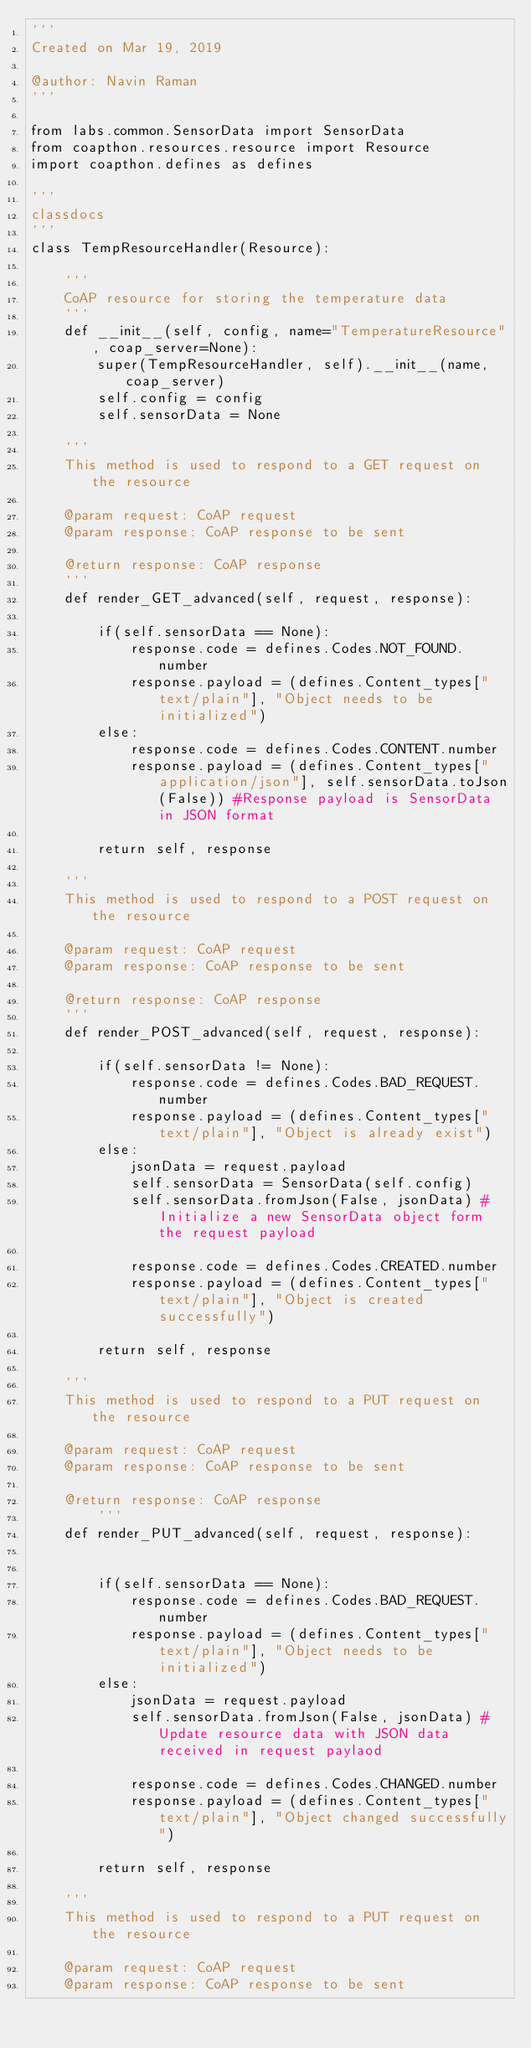<code> <loc_0><loc_0><loc_500><loc_500><_Python_>'''
Created on Mar 19, 2019

@author: Navin Raman
'''

from labs.common.SensorData import SensorData
from coapthon.resources.resource import Resource
import coapthon.defines as defines

'''
classdocs
'''
class TempResourceHandler(Resource):
    
    '''
    CoAP resource for storing the temperature data
    '''
    def __init__(self, config, name="TemperatureResource", coap_server=None):
        super(TempResourceHandler, self).__init__(name, coap_server)
        self.config = config
        self.sensorData = None
    
    '''
    This method is used to respond to a GET request on the resource
        
    @param request: CoAP request
    @param response: CoAP response to be sent

    @return response: CoAP response
    '''
    def render_GET_advanced(self, request, response):
        
        if(self.sensorData == None):
            response.code = defines.Codes.NOT_FOUND.number
            response.payload = (defines.Content_types["text/plain"], "Object needs to be initialized")
        else:
            response.code = defines.Codes.CONTENT.number
            response.payload = (defines.Content_types["application/json"], self.sensorData.toJson(False)) #Response payload is SensorData in JSON format    
            
        return self, response
                
    '''
    This method is used to respond to a POST request on the resource
        
    @param request: CoAP request
    @param response: CoAP response to be sent

    @return response: CoAP response
    '''            
    def render_POST_advanced(self, request, response):
             
        if(self.sensorData != None):
            response.code = defines.Codes.BAD_REQUEST.number
            response.payload = (defines.Content_types["text/plain"], "Object is already exist")
        else:
            jsonData = request.payload
            self.sensorData = SensorData(self.config)
            self.sensorData.fromJson(False, jsonData) #Initialize a new SensorData object form the request payload
                
            response.code = defines.Codes.CREATED.number
            response.payload = (defines.Content_types["text/plain"], "Object is created successfully")    
            
        return self, response
        
    '''
    This method is used to respond to a PUT request on the resource
        
    @param request: CoAP request
    @param response: CoAP response to be sent

    @return response: CoAP response
        '''    
    def render_PUT_advanced(self, request, response):
        
        
        if(self.sensorData == None):
            response.code = defines.Codes.BAD_REQUEST.number
            response.payload = (defines.Content_types["text/plain"], "Object needs to be initialized")
        else:
            jsonData = request.payload
            self.sensorData.fromJson(False, jsonData) #Update resource data with JSON data received in request paylaod
                
            response.code = defines.Codes.CHANGED.number
            response.payload = (defines.Content_types["text/plain"], "Object changed successfully")    
            
        return self, response
     
    '''
    This method is used to respond to a PUT request on the resource
        
    @param request: CoAP request
    @param response: CoAP response to be sent
</code> 